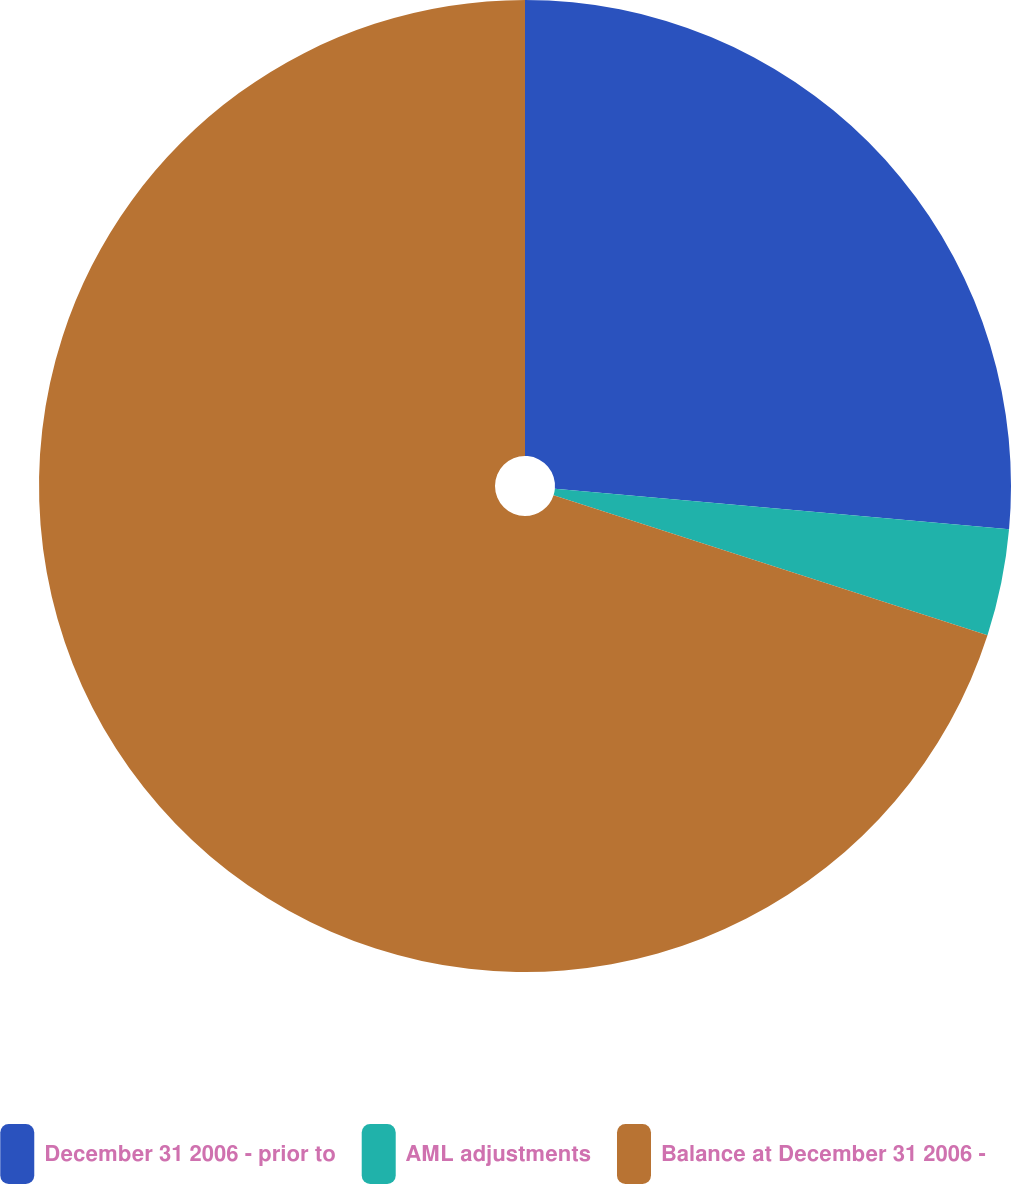Convert chart to OTSL. <chart><loc_0><loc_0><loc_500><loc_500><pie_chart><fcel>December 31 2006 - prior to<fcel>AML adjustments<fcel>Balance at December 31 2006 -<nl><fcel>26.42%<fcel>3.55%<fcel>70.03%<nl></chart> 